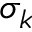Convert formula to latex. <formula><loc_0><loc_0><loc_500><loc_500>\sigma _ { k }</formula> 